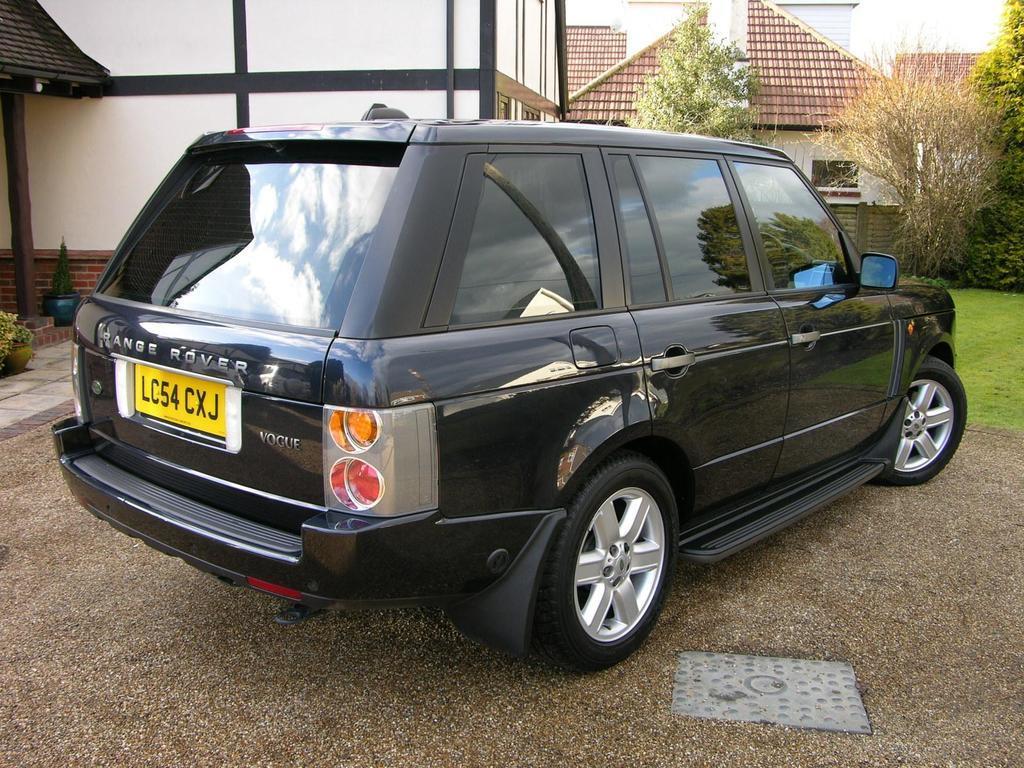Please provide a concise description of this image. In this picture there is a black car which is parked near to the building. In the background I can see the windows, trees, plants and grass. At the top there is a sky. 